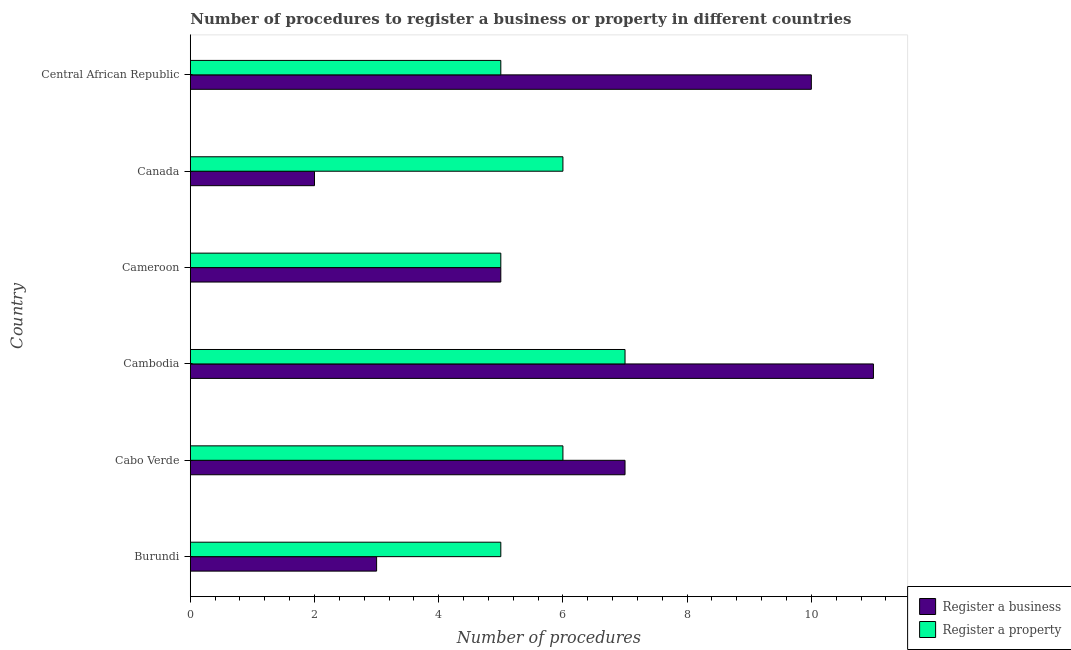How many different coloured bars are there?
Keep it short and to the point. 2. How many groups of bars are there?
Offer a terse response. 6. Are the number of bars per tick equal to the number of legend labels?
Give a very brief answer. Yes. Are the number of bars on each tick of the Y-axis equal?
Provide a short and direct response. Yes. What is the label of the 5th group of bars from the top?
Ensure brevity in your answer.  Cabo Verde. What is the number of procedures to register a business in Burundi?
Provide a short and direct response. 3. Across all countries, what is the minimum number of procedures to register a business?
Your answer should be compact. 2. In which country was the number of procedures to register a business maximum?
Keep it short and to the point. Cambodia. In which country was the number of procedures to register a property minimum?
Your answer should be very brief. Burundi. What is the total number of procedures to register a business in the graph?
Make the answer very short. 38. What is the difference between the number of procedures to register a business in Cambodia and that in Canada?
Offer a very short reply. 9. What is the difference between the number of procedures to register a business in Cameroon and the number of procedures to register a property in Cambodia?
Make the answer very short. -2. What is the average number of procedures to register a property per country?
Your answer should be compact. 5.67. In how many countries, is the number of procedures to register a business greater than 3.2 ?
Ensure brevity in your answer.  4. What is the ratio of the number of procedures to register a property in Canada to that in Central African Republic?
Offer a very short reply. 1.2. Is the difference between the number of procedures to register a property in Cameroon and Central African Republic greater than the difference between the number of procedures to register a business in Cameroon and Central African Republic?
Ensure brevity in your answer.  Yes. What is the difference between the highest and the second highest number of procedures to register a property?
Offer a terse response. 1. In how many countries, is the number of procedures to register a business greater than the average number of procedures to register a business taken over all countries?
Offer a very short reply. 3. Is the sum of the number of procedures to register a business in Canada and Central African Republic greater than the maximum number of procedures to register a property across all countries?
Keep it short and to the point. Yes. What does the 1st bar from the top in Cabo Verde represents?
Offer a terse response. Register a property. What does the 2nd bar from the bottom in Canada represents?
Offer a very short reply. Register a property. How many bars are there?
Ensure brevity in your answer.  12. Are the values on the major ticks of X-axis written in scientific E-notation?
Your response must be concise. No. Does the graph contain grids?
Provide a succinct answer. No. How are the legend labels stacked?
Your response must be concise. Vertical. What is the title of the graph?
Offer a terse response. Number of procedures to register a business or property in different countries. Does "Fraud firms" appear as one of the legend labels in the graph?
Make the answer very short. No. What is the label or title of the X-axis?
Your answer should be very brief. Number of procedures. What is the label or title of the Y-axis?
Your answer should be compact. Country. What is the Number of procedures of Register a property in Burundi?
Ensure brevity in your answer.  5. What is the Number of procedures of Register a business in Cabo Verde?
Your answer should be very brief. 7. What is the Number of procedures in Register a property in Cambodia?
Give a very brief answer. 7. What is the Number of procedures of Register a property in Canada?
Your answer should be very brief. 6. Across all countries, what is the maximum Number of procedures in Register a business?
Your response must be concise. 11. What is the total Number of procedures in Register a business in the graph?
Give a very brief answer. 38. What is the difference between the Number of procedures in Register a business in Burundi and that in Cabo Verde?
Keep it short and to the point. -4. What is the difference between the Number of procedures in Register a property in Burundi and that in Cabo Verde?
Offer a terse response. -1. What is the difference between the Number of procedures in Register a business in Burundi and that in Cambodia?
Provide a succinct answer. -8. What is the difference between the Number of procedures in Register a business in Burundi and that in Cameroon?
Give a very brief answer. -2. What is the difference between the Number of procedures of Register a property in Burundi and that in Cameroon?
Give a very brief answer. 0. What is the difference between the Number of procedures in Register a property in Burundi and that in Canada?
Provide a succinct answer. -1. What is the difference between the Number of procedures in Register a business in Burundi and that in Central African Republic?
Keep it short and to the point. -7. What is the difference between the Number of procedures in Register a property in Cabo Verde and that in Canada?
Provide a succinct answer. 0. What is the difference between the Number of procedures in Register a business in Cambodia and that in Canada?
Offer a terse response. 9. What is the difference between the Number of procedures in Register a business in Cameroon and that in Central African Republic?
Ensure brevity in your answer.  -5. What is the difference between the Number of procedures of Register a property in Cameroon and that in Central African Republic?
Make the answer very short. 0. What is the difference between the Number of procedures of Register a business in Canada and that in Central African Republic?
Offer a terse response. -8. What is the difference between the Number of procedures in Register a business in Burundi and the Number of procedures in Register a property in Cabo Verde?
Keep it short and to the point. -3. What is the difference between the Number of procedures of Register a business in Burundi and the Number of procedures of Register a property in Cameroon?
Offer a terse response. -2. What is the difference between the Number of procedures in Register a business in Burundi and the Number of procedures in Register a property in Canada?
Provide a succinct answer. -3. What is the difference between the Number of procedures in Register a business in Cabo Verde and the Number of procedures in Register a property in Canada?
Your answer should be compact. 1. What is the difference between the Number of procedures of Register a business in Cambodia and the Number of procedures of Register a property in Cameroon?
Provide a short and direct response. 6. What is the difference between the Number of procedures of Register a business in Cameroon and the Number of procedures of Register a property in Central African Republic?
Your answer should be very brief. 0. What is the difference between the Number of procedures of Register a business in Canada and the Number of procedures of Register a property in Central African Republic?
Offer a very short reply. -3. What is the average Number of procedures of Register a business per country?
Give a very brief answer. 6.33. What is the average Number of procedures in Register a property per country?
Keep it short and to the point. 5.67. What is the difference between the Number of procedures of Register a business and Number of procedures of Register a property in Burundi?
Provide a short and direct response. -2. What is the difference between the Number of procedures in Register a business and Number of procedures in Register a property in Cabo Verde?
Your answer should be very brief. 1. What is the difference between the Number of procedures of Register a business and Number of procedures of Register a property in Cameroon?
Make the answer very short. 0. What is the ratio of the Number of procedures of Register a business in Burundi to that in Cabo Verde?
Make the answer very short. 0.43. What is the ratio of the Number of procedures in Register a business in Burundi to that in Cambodia?
Give a very brief answer. 0.27. What is the ratio of the Number of procedures in Register a business in Burundi to that in Central African Republic?
Give a very brief answer. 0.3. What is the ratio of the Number of procedures of Register a property in Burundi to that in Central African Republic?
Ensure brevity in your answer.  1. What is the ratio of the Number of procedures in Register a business in Cabo Verde to that in Cambodia?
Your answer should be very brief. 0.64. What is the ratio of the Number of procedures in Register a property in Cabo Verde to that in Cambodia?
Give a very brief answer. 0.86. What is the ratio of the Number of procedures in Register a business in Cabo Verde to that in Cameroon?
Offer a terse response. 1.4. What is the ratio of the Number of procedures in Register a business in Cabo Verde to that in Canada?
Make the answer very short. 3.5. What is the ratio of the Number of procedures of Register a property in Cabo Verde to that in Canada?
Your answer should be very brief. 1. What is the ratio of the Number of procedures in Register a business in Cabo Verde to that in Central African Republic?
Keep it short and to the point. 0.7. What is the ratio of the Number of procedures in Register a business in Cambodia to that in Cameroon?
Your answer should be very brief. 2.2. What is the ratio of the Number of procedures of Register a property in Cambodia to that in Canada?
Your response must be concise. 1.17. What is the ratio of the Number of procedures of Register a business in Cambodia to that in Central African Republic?
Your answer should be compact. 1.1. What is the ratio of the Number of procedures of Register a property in Cambodia to that in Central African Republic?
Offer a terse response. 1.4. What is the difference between the highest and the second highest Number of procedures of Register a property?
Your answer should be very brief. 1. What is the difference between the highest and the lowest Number of procedures in Register a property?
Keep it short and to the point. 2. 